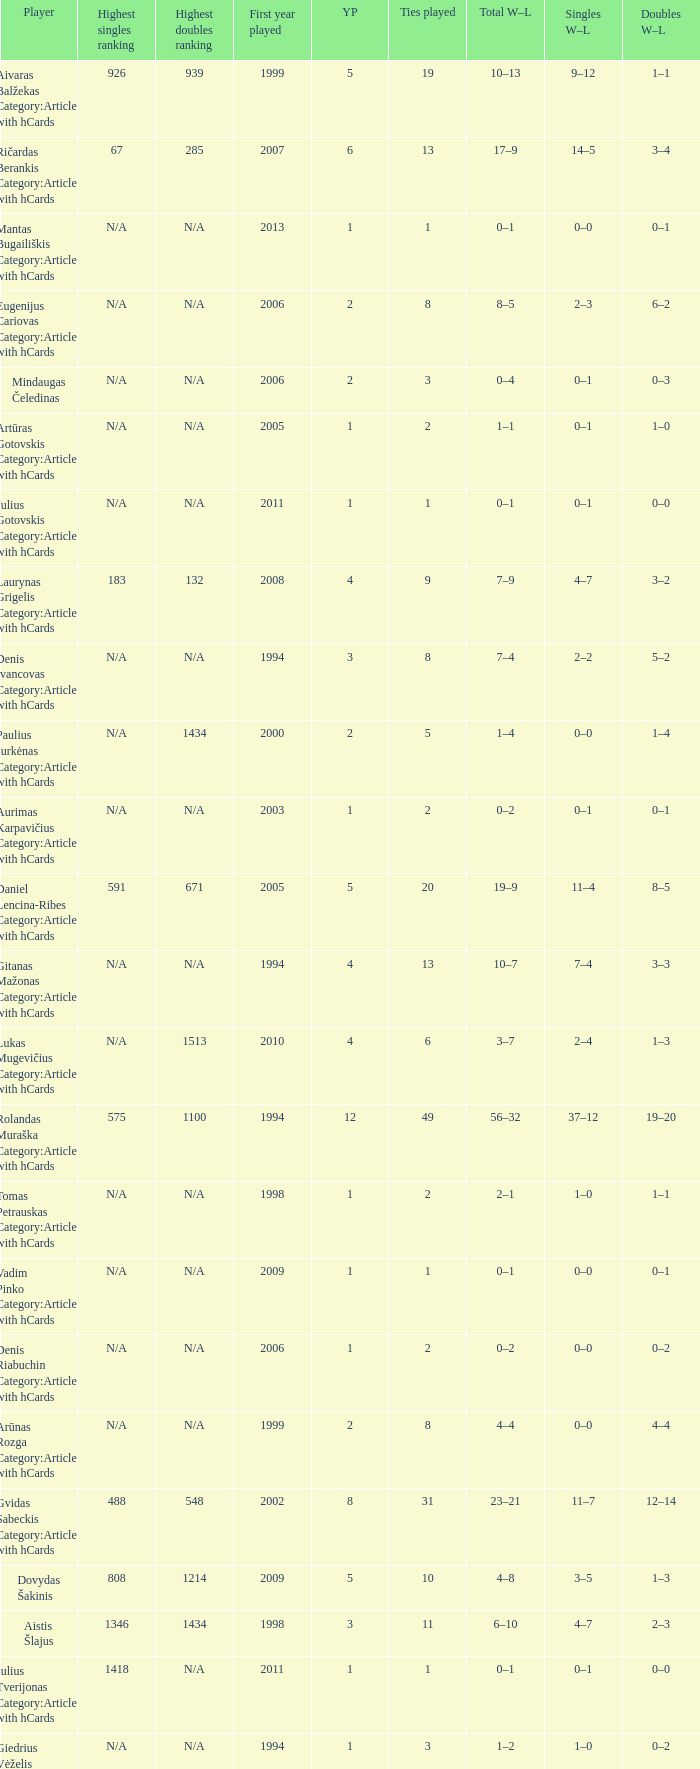Name the minimum tiesplayed for 6 years 13.0. 